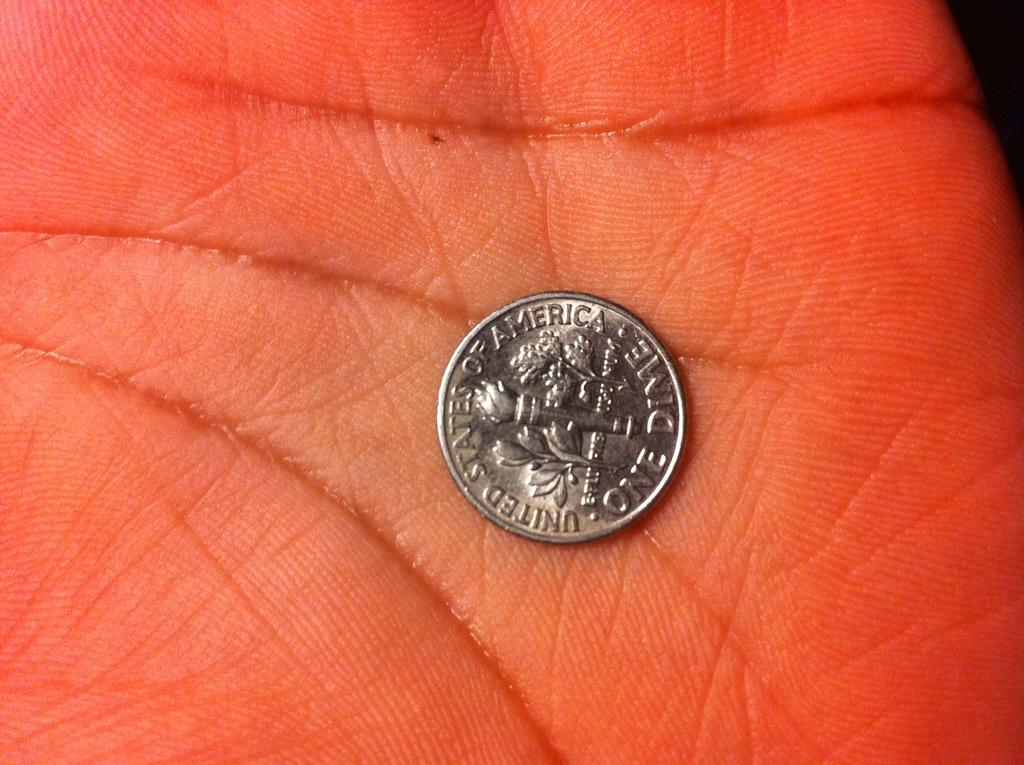<image>
Give a short and clear explanation of the subsequent image. a coin that has the word america on it 